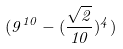Convert formula to latex. <formula><loc_0><loc_0><loc_500><loc_500>( 9 ^ { 1 0 } - ( \frac { \sqrt { 2 } } { 1 0 } ) ^ { 4 } )</formula> 